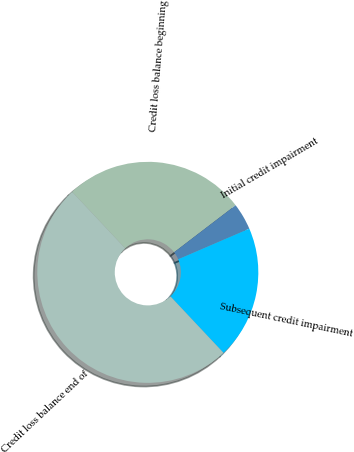<chart> <loc_0><loc_0><loc_500><loc_500><pie_chart><fcel>Credit loss balance beginning<fcel>Initial credit impairment<fcel>Subsequent credit impairment<fcel>Credit loss balance end of<nl><fcel>26.62%<fcel>3.92%<fcel>19.46%<fcel>50.0%<nl></chart> 